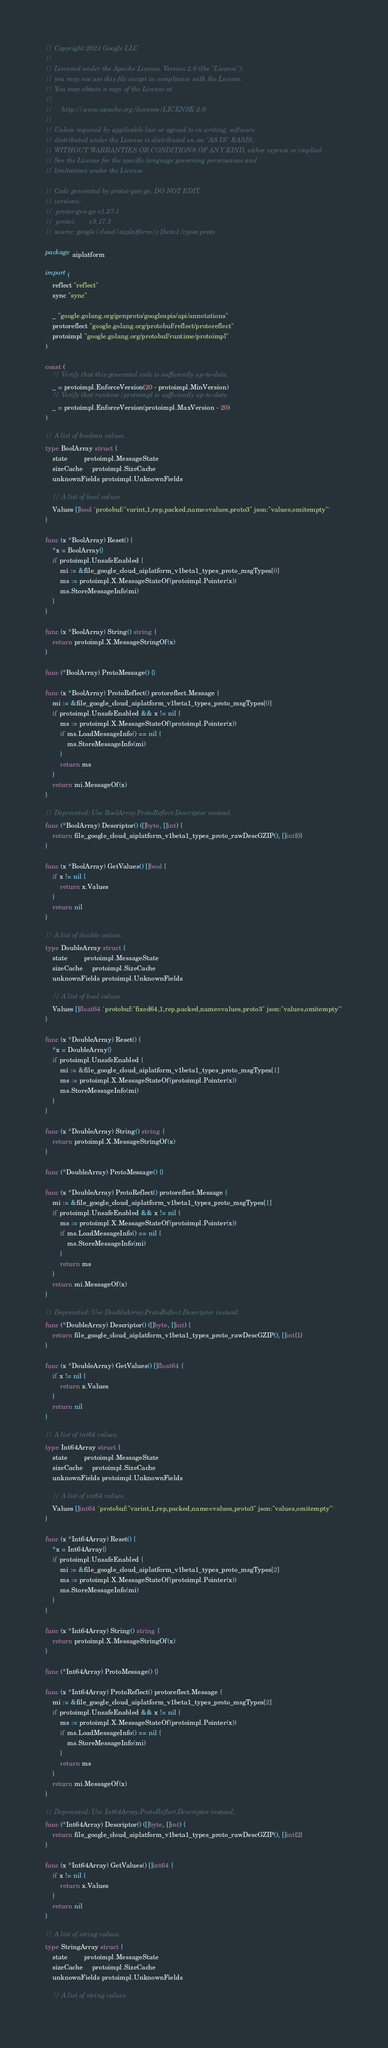<code> <loc_0><loc_0><loc_500><loc_500><_Go_>// Copyright 2021 Google LLC
//
// Licensed under the Apache License, Version 2.0 (the "License");
// you may not use this file except in compliance with the License.
// You may obtain a copy of the License at
//
//     http://www.apache.org/licenses/LICENSE-2.0
//
// Unless required by applicable law or agreed to in writing, software
// distributed under the License is distributed on an "AS IS" BASIS,
// WITHOUT WARRANTIES OR CONDITIONS OF ANY KIND, either express or implied.
// See the License for the specific language governing permissions and
// limitations under the License.

// Code generated by protoc-gen-go. DO NOT EDIT.
// versions:
// 	protoc-gen-go v1.27.1
// 	protoc        v3.17.3
// source: google/cloud/aiplatform/v1beta1/types.proto

package aiplatform

import (
	reflect "reflect"
	sync "sync"

	_ "google.golang.org/genproto/googleapis/api/annotations"
	protoreflect "google.golang.org/protobuf/reflect/protoreflect"
	protoimpl "google.golang.org/protobuf/runtime/protoimpl"
)

const (
	// Verify that this generated code is sufficiently up-to-date.
	_ = protoimpl.EnforceVersion(20 - protoimpl.MinVersion)
	// Verify that runtime/protoimpl is sufficiently up-to-date.
	_ = protoimpl.EnforceVersion(protoimpl.MaxVersion - 20)
)

// A list of boolean values.
type BoolArray struct {
	state         protoimpl.MessageState
	sizeCache     protoimpl.SizeCache
	unknownFields protoimpl.UnknownFields

	// A list of bool values.
	Values []bool `protobuf:"varint,1,rep,packed,name=values,proto3" json:"values,omitempty"`
}

func (x *BoolArray) Reset() {
	*x = BoolArray{}
	if protoimpl.UnsafeEnabled {
		mi := &file_google_cloud_aiplatform_v1beta1_types_proto_msgTypes[0]
		ms := protoimpl.X.MessageStateOf(protoimpl.Pointer(x))
		ms.StoreMessageInfo(mi)
	}
}

func (x *BoolArray) String() string {
	return protoimpl.X.MessageStringOf(x)
}

func (*BoolArray) ProtoMessage() {}

func (x *BoolArray) ProtoReflect() protoreflect.Message {
	mi := &file_google_cloud_aiplatform_v1beta1_types_proto_msgTypes[0]
	if protoimpl.UnsafeEnabled && x != nil {
		ms := protoimpl.X.MessageStateOf(protoimpl.Pointer(x))
		if ms.LoadMessageInfo() == nil {
			ms.StoreMessageInfo(mi)
		}
		return ms
	}
	return mi.MessageOf(x)
}

// Deprecated: Use BoolArray.ProtoReflect.Descriptor instead.
func (*BoolArray) Descriptor() ([]byte, []int) {
	return file_google_cloud_aiplatform_v1beta1_types_proto_rawDescGZIP(), []int{0}
}

func (x *BoolArray) GetValues() []bool {
	if x != nil {
		return x.Values
	}
	return nil
}

// A list of double values.
type DoubleArray struct {
	state         protoimpl.MessageState
	sizeCache     protoimpl.SizeCache
	unknownFields protoimpl.UnknownFields

	// A list of bool values.
	Values []float64 `protobuf:"fixed64,1,rep,packed,name=values,proto3" json:"values,omitempty"`
}

func (x *DoubleArray) Reset() {
	*x = DoubleArray{}
	if protoimpl.UnsafeEnabled {
		mi := &file_google_cloud_aiplatform_v1beta1_types_proto_msgTypes[1]
		ms := protoimpl.X.MessageStateOf(protoimpl.Pointer(x))
		ms.StoreMessageInfo(mi)
	}
}

func (x *DoubleArray) String() string {
	return protoimpl.X.MessageStringOf(x)
}

func (*DoubleArray) ProtoMessage() {}

func (x *DoubleArray) ProtoReflect() protoreflect.Message {
	mi := &file_google_cloud_aiplatform_v1beta1_types_proto_msgTypes[1]
	if protoimpl.UnsafeEnabled && x != nil {
		ms := protoimpl.X.MessageStateOf(protoimpl.Pointer(x))
		if ms.LoadMessageInfo() == nil {
			ms.StoreMessageInfo(mi)
		}
		return ms
	}
	return mi.MessageOf(x)
}

// Deprecated: Use DoubleArray.ProtoReflect.Descriptor instead.
func (*DoubleArray) Descriptor() ([]byte, []int) {
	return file_google_cloud_aiplatform_v1beta1_types_proto_rawDescGZIP(), []int{1}
}

func (x *DoubleArray) GetValues() []float64 {
	if x != nil {
		return x.Values
	}
	return nil
}

// A list of int64 values.
type Int64Array struct {
	state         protoimpl.MessageState
	sizeCache     protoimpl.SizeCache
	unknownFields protoimpl.UnknownFields

	// A list of int64 values.
	Values []int64 `protobuf:"varint,1,rep,packed,name=values,proto3" json:"values,omitempty"`
}

func (x *Int64Array) Reset() {
	*x = Int64Array{}
	if protoimpl.UnsafeEnabled {
		mi := &file_google_cloud_aiplatform_v1beta1_types_proto_msgTypes[2]
		ms := protoimpl.X.MessageStateOf(protoimpl.Pointer(x))
		ms.StoreMessageInfo(mi)
	}
}

func (x *Int64Array) String() string {
	return protoimpl.X.MessageStringOf(x)
}

func (*Int64Array) ProtoMessage() {}

func (x *Int64Array) ProtoReflect() protoreflect.Message {
	mi := &file_google_cloud_aiplatform_v1beta1_types_proto_msgTypes[2]
	if protoimpl.UnsafeEnabled && x != nil {
		ms := protoimpl.X.MessageStateOf(protoimpl.Pointer(x))
		if ms.LoadMessageInfo() == nil {
			ms.StoreMessageInfo(mi)
		}
		return ms
	}
	return mi.MessageOf(x)
}

// Deprecated: Use Int64Array.ProtoReflect.Descriptor instead.
func (*Int64Array) Descriptor() ([]byte, []int) {
	return file_google_cloud_aiplatform_v1beta1_types_proto_rawDescGZIP(), []int{2}
}

func (x *Int64Array) GetValues() []int64 {
	if x != nil {
		return x.Values
	}
	return nil
}

// A list of string values.
type StringArray struct {
	state         protoimpl.MessageState
	sizeCache     protoimpl.SizeCache
	unknownFields protoimpl.UnknownFields

	// A list of string values.</code> 